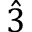Convert formula to latex. <formula><loc_0><loc_0><loc_500><loc_500>\hat { 3 }</formula> 